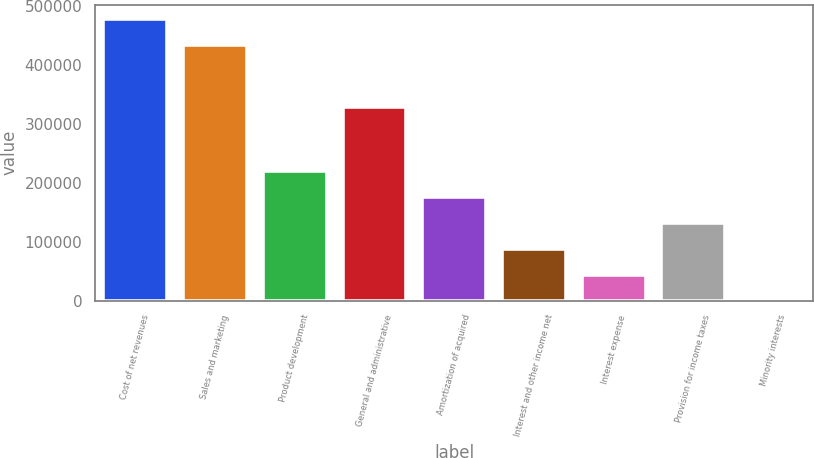<chart> <loc_0><loc_0><loc_500><loc_500><bar_chart><fcel>Cost of net revenues<fcel>Sales and marketing<fcel>Product development<fcel>General and administrative<fcel>Amortization of acquired<fcel>Interest and other income net<fcel>Interest expense<fcel>Provision for income taxes<fcel>Minority interests<nl><fcel>477792<fcel>433928<fcel>219366<fcel>328834<fcel>175502<fcel>87773.6<fcel>43909.3<fcel>131638<fcel>45<nl></chart> 